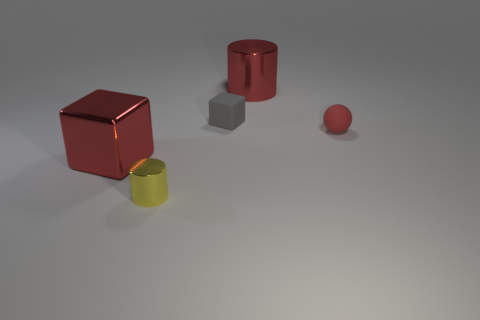Add 4 blocks. How many objects exist? 9 Subtract all cylinders. How many objects are left? 3 Add 1 yellow metal cylinders. How many yellow metal cylinders are left? 2 Add 5 tiny cyan shiny blocks. How many tiny cyan shiny blocks exist? 5 Subtract 0 green cylinders. How many objects are left? 5 Subtract all small rubber cubes. Subtract all red objects. How many objects are left? 1 